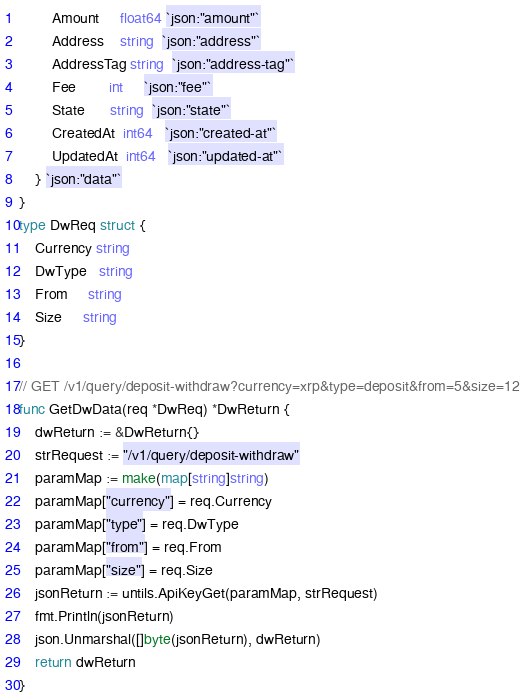<code> <loc_0><loc_0><loc_500><loc_500><_Go_>		Amount     float64 `json:"amount"`
		Address    string  `json:"address"`
		AddressTag string  `json:"address-tag"`
		Fee        int     `json:"fee"`
		State      string  `json:"state"`
		CreatedAt  int64   `json:"created-at"`
		UpdatedAt  int64   `json:"updated-at"`
	} `json:"data"`
}
type DwReq struct {
	Currency string
	DwType   string
	From     string
	Size     string
}

// GET /v1/query/deposit-withdraw?currency=xrp&type=deposit&from=5&size=12
func GetDwData(req *DwReq) *DwReturn {
	dwReturn := &DwReturn{}
	strRequest := "/v1/query/deposit-withdraw"
	paramMap := make(map[string]string)
	paramMap["currency"] = req.Currency
	paramMap["type"] = req.DwType
	paramMap["from"] = req.From
	paramMap["size"] = req.Size
	jsonReturn := untils.ApiKeyGet(paramMap, strRequest)
	fmt.Println(jsonReturn)
	json.Unmarshal([]byte(jsonReturn), dwReturn)
	return dwReturn
}
</code> 